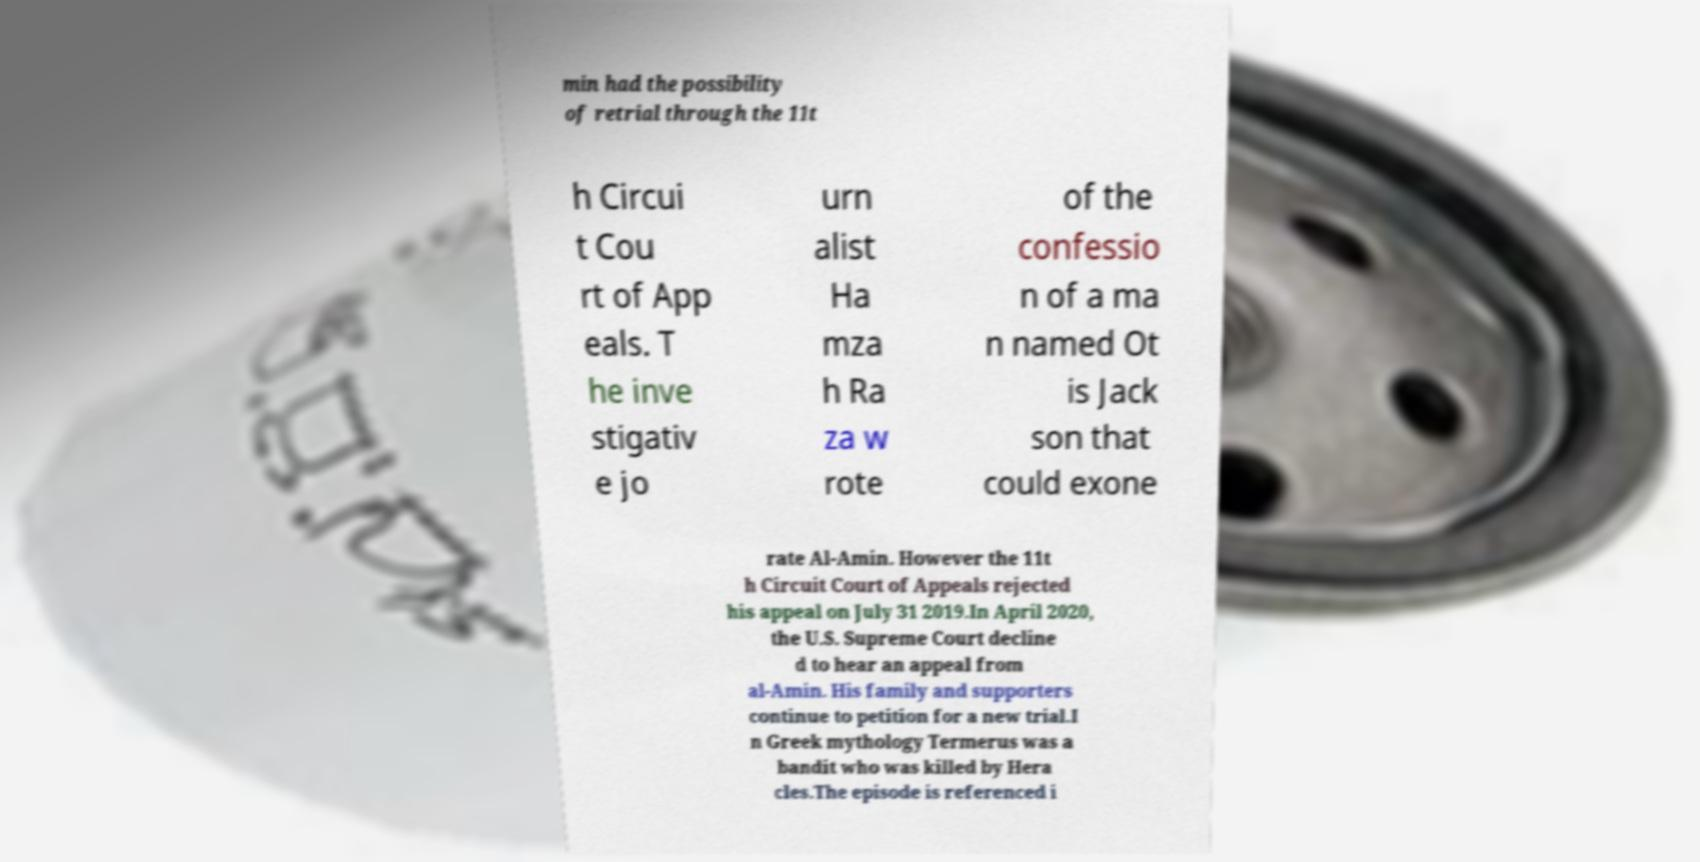Can you accurately transcribe the text from the provided image for me? min had the possibility of retrial through the 11t h Circui t Cou rt of App eals. T he inve stigativ e jo urn alist Ha mza h Ra za w rote of the confessio n of a ma n named Ot is Jack son that could exone rate Al-Amin. However the 11t h Circuit Court of Appeals rejected his appeal on July 31 2019.In April 2020, the U.S. Supreme Court decline d to hear an appeal from al-Amin. His family and supporters continue to petition for a new trial.I n Greek mythology Termerus was a bandit who was killed by Hera cles.The episode is referenced i 